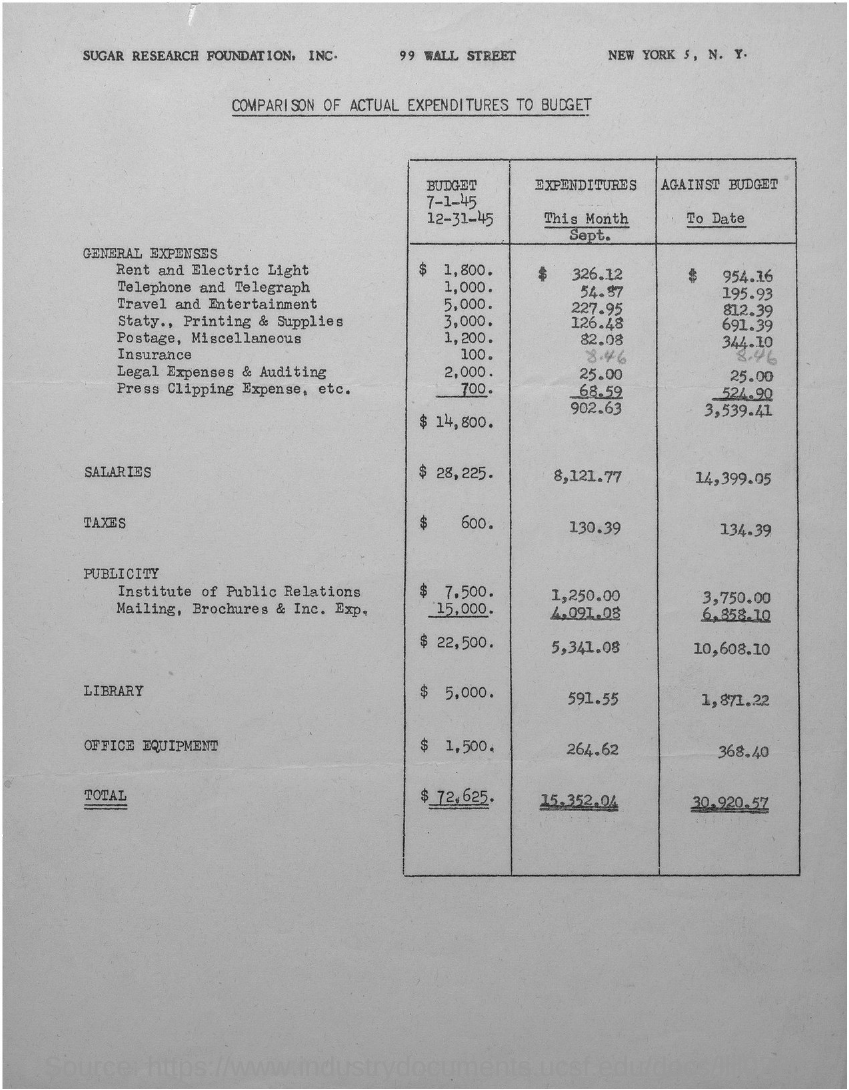What type of comparison is given in this document?
Keep it short and to the point. Comparison of actual expenditures to budget. What is the salary expenditure for the month of september?
Offer a very short reply. 8,121.77. What is the amount of salaries against the budget to date?
Keep it short and to the point. 14,399.05. What is the total expenditure for the month of september?
Give a very brief answer. 15,352.04. What is the total general expenses for the month of september?
Keep it short and to the point. 902.63. What is the total general expenses against the budget to date?
Provide a succinct answer. 3,539.41. What are the taxes against the budget to date?
Your answer should be compact. 134.39. 